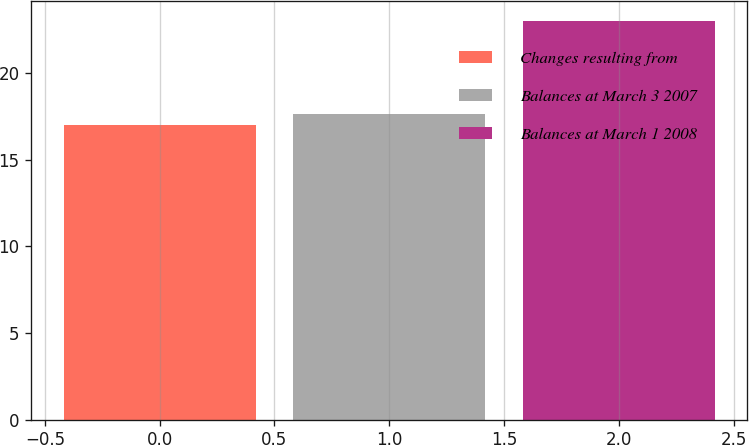<chart> <loc_0><loc_0><loc_500><loc_500><bar_chart><fcel>Changes resulting from<fcel>Balances at March 3 2007<fcel>Balances at March 1 2008<nl><fcel>17<fcel>17.6<fcel>23<nl></chart> 